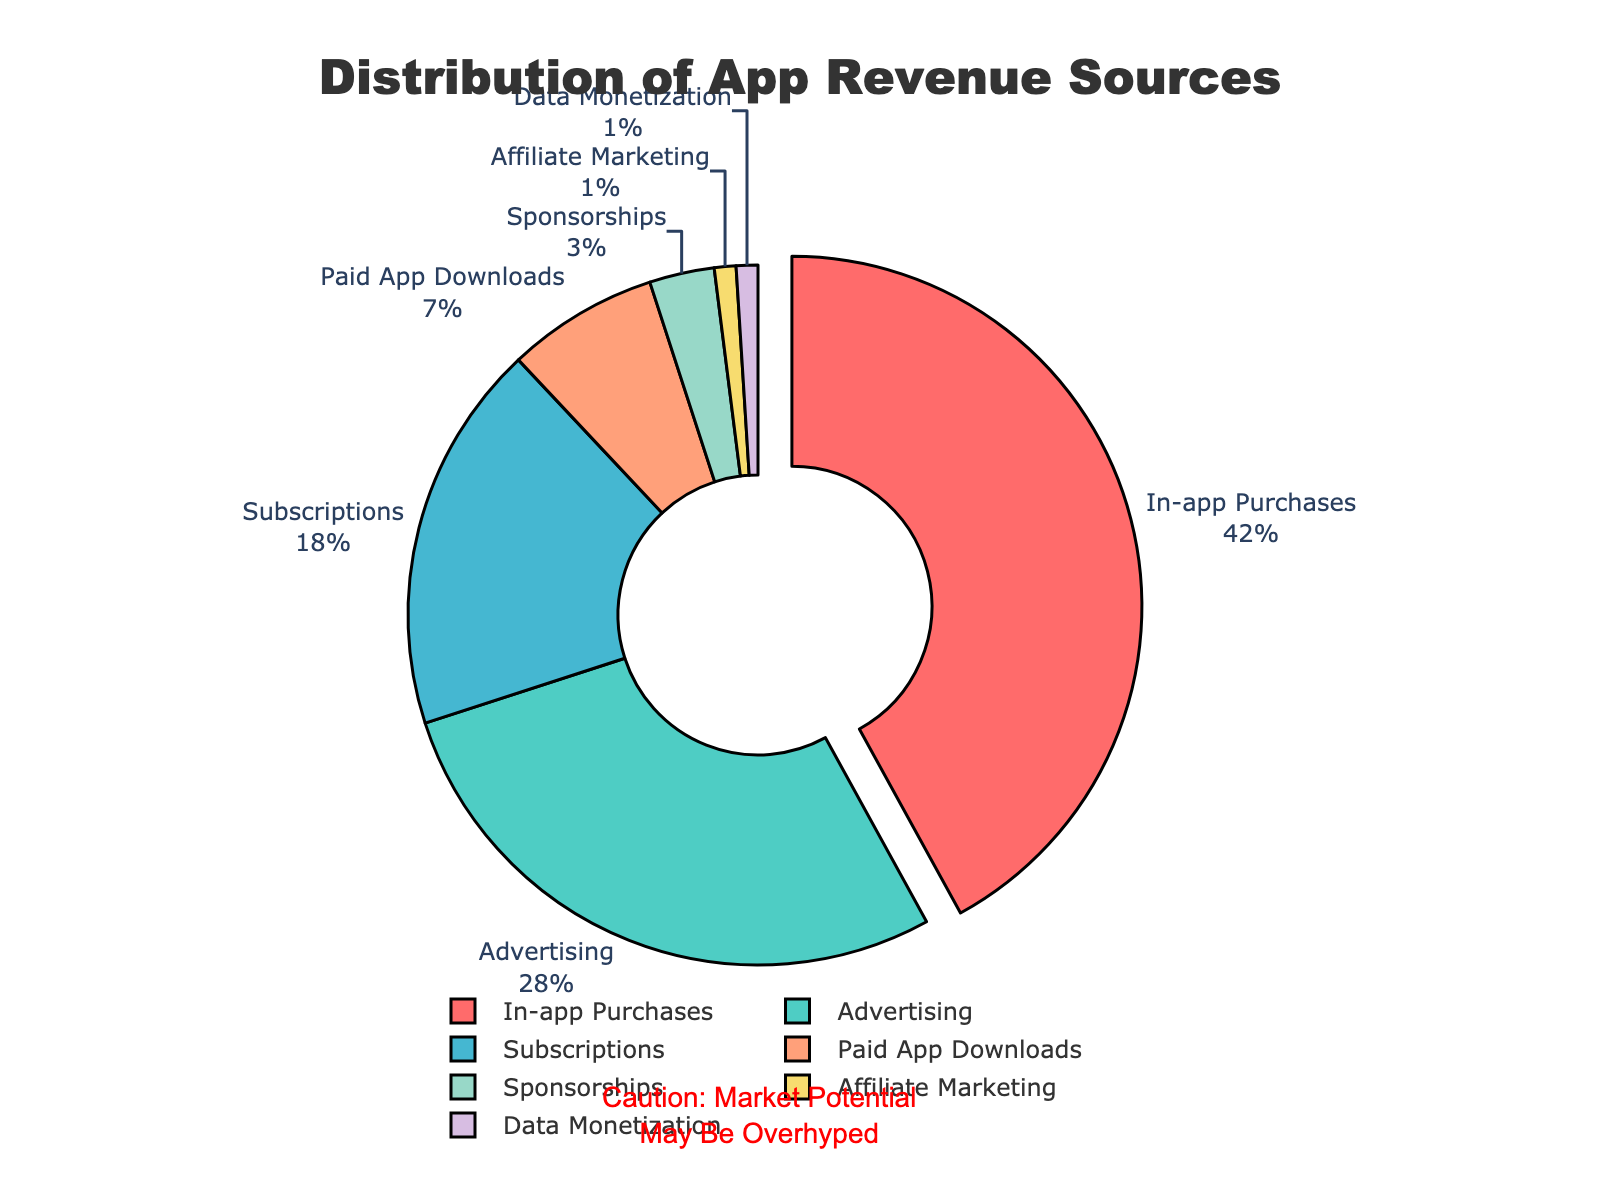What is the largest source of revenue for the app? The figure shows that in-app purchases account for the largest percentage of revenue at 42%. Look for the segment with the highest percentage.
Answer: In-app purchases What is the combined percentage of revenue from subscriptions and paid app downloads? Add the percentages of subscriptions (18%) and paid app downloads (7%) to get the answer. 18 + 7 = 25
Answer: 25% Where does the app earn more, from advertising or from data monetization? Advertising contributes 28% and data monetization contributes only 1%. Compare these percentages.
Answer: Advertising Is the revenue from sponsorships greater than that from affiliate marketing? The figure shows sponsorships at 3% and affiliate marketing at 1%. Compare these two percentages.
Answer: Yes What portion of the total revenue is accounted for by sources outside of in-app purchases and advertising? Subtract the combined percentage of in-app purchases (42%) and advertising (28%) from 100%. 100 - 42 - 28 = 30%
Answer: 30% How many categories collectively make up the smallest 10% of revenue? Sponsorships (3%), affiliate marketing (1%), and data monetization (1%) together make up the smallest portion, totaling 3% + 1% + 1% = 5%.
Answer: 3 categories What color is the segment representing advertising revenue? Identify the segment labeled advertising and note its color, which is represented in green according to the custom color palette.
Answer: Green How much larger is the revenue from in-app purchases compared to subscriptions? Subtract the percentage of subscriptions (18%) from in-app purchases (42%). 42 - 18 = 24
Answer: 24% Which segment is highlighted or pulled out from the center of the pie chart? The figure highlights the largest segment, in-app purchases, by pulling it out. Look for the segment that is detached from the center.
Answer: In-app purchases How does the revenue from paid app downloads compare to that from advertising and what are their respective colors? Paid app downloads contribute 7%, while advertising contributes 28%. Identify the colors for these segments: paid app downloads are light orange, and advertising is green.
Answer: Paid app downloads are 21% less, light orange and green 